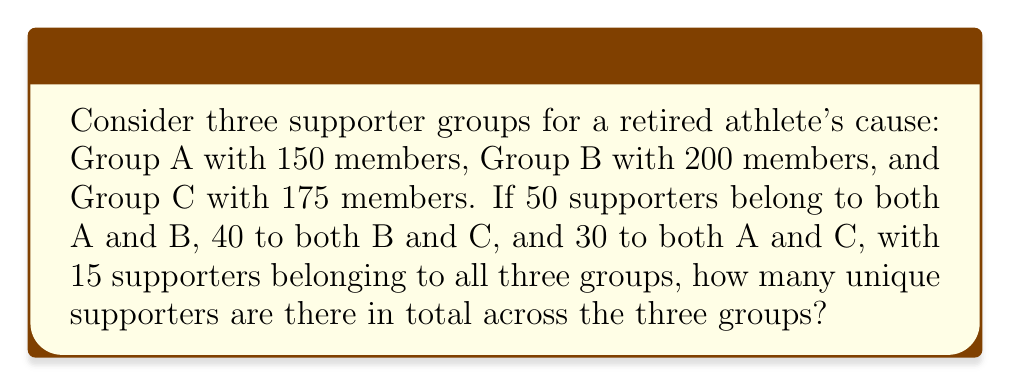Show me your answer to this math problem. To solve this problem, we'll use set theory and the principle of inclusion-exclusion.

Let's define our sets:
$A$: supporters in Group A
$B$: supporters in Group B
$C$: supporters in Group C

We're given:
$|A| = 150$, $|B| = 200$, $|C| = 175$
$|A \cap B| = 50$, $|B \cap C| = 40$, $|A \cap C| = 30$
$|A \cap B \cap C| = 15$

The principle of inclusion-exclusion for three sets states:

$$|A \cup B \cup C| = |A| + |B| + |C| - |A \cap B| - |B \cap C| - |A \cap C| + |A \cap B \cap C|$$

Let's substitute our known values:

$$|A \cup B \cup C| = 150 + 200 + 175 - 50 - 40 - 30 + 15$$

Now we can calculate:

$$|A \cup B \cup C| = 525 - 120 + 15 = 420$$

Therefore, there are 420 unique supporters across the three groups.
Answer: 420 unique supporters 